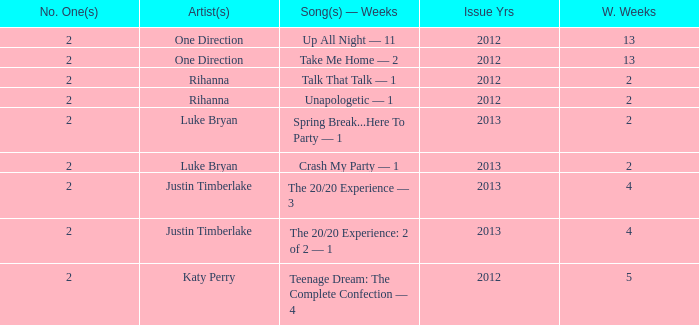What is the title of every song, and how many weeks was each song at #1 for One Direction? Up All Night — 11, Take Me Home — 2. 